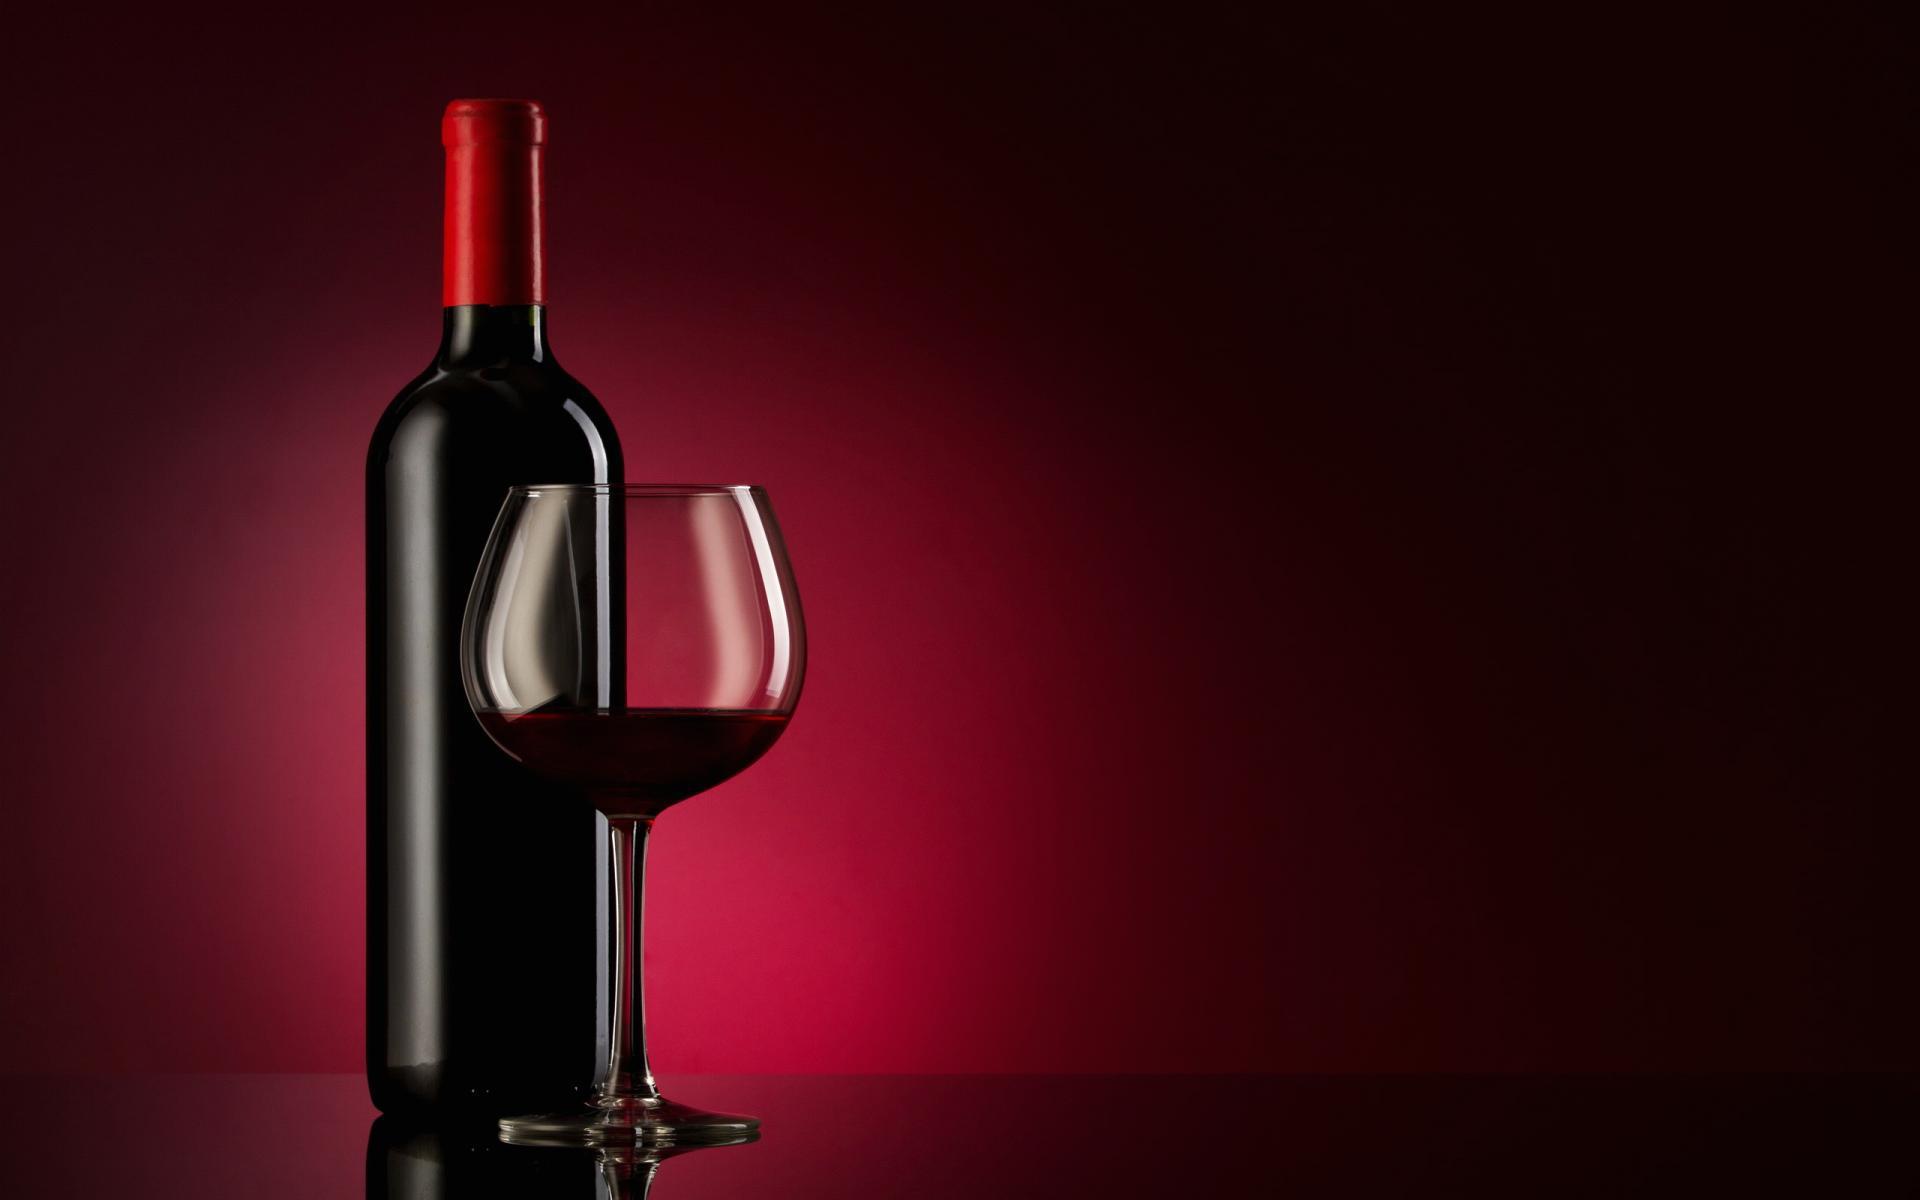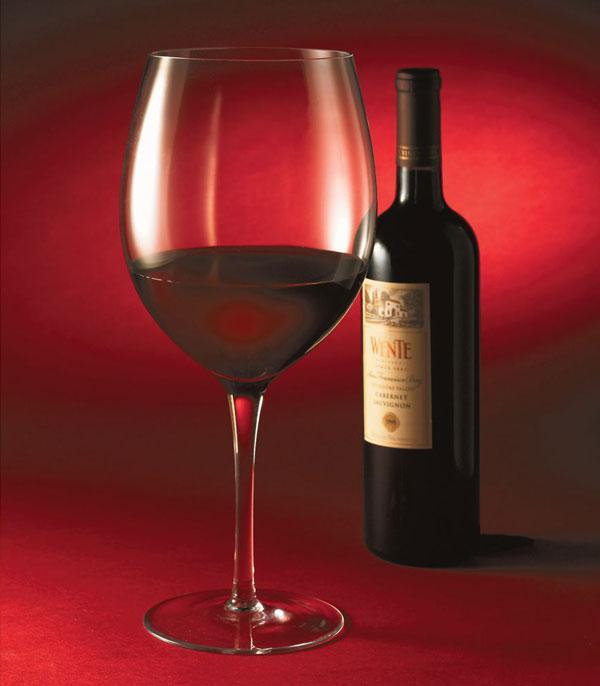The first image is the image on the left, the second image is the image on the right. Evaluate the accuracy of this statement regarding the images: "One of the images has a bottle in a holder paired with a bottle with a label, but all wine bottles are otherwise without labels.". Is it true? Answer yes or no. No. 